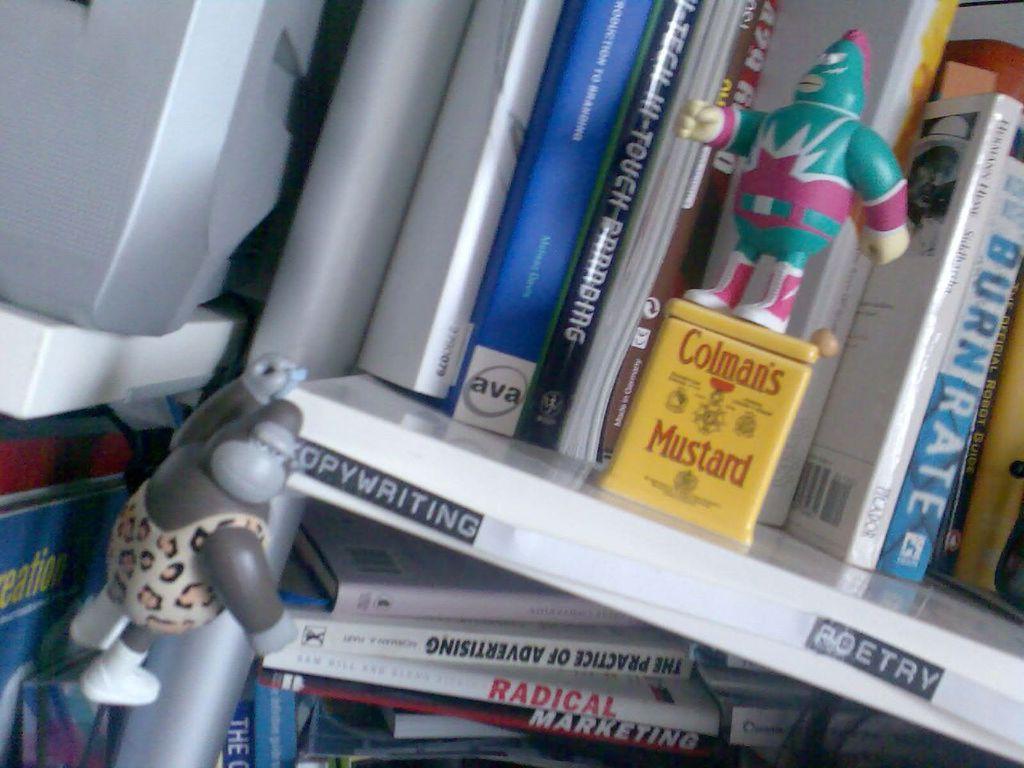What is the words in red?
Ensure brevity in your answer.  Colman's mustard. 